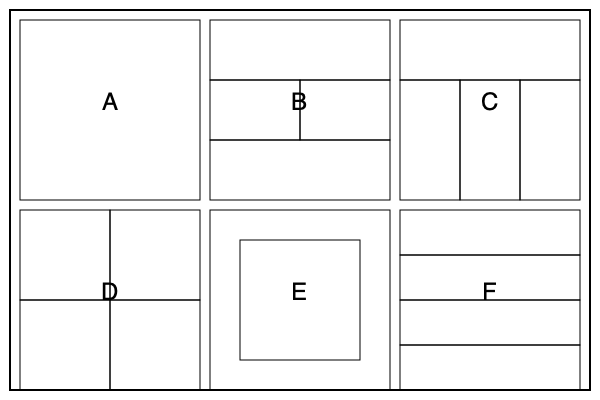Analyze the six panel layout grids (A-F) shown above. Which layout would be most effective for depicting a tense confrontation between two characters, where one character gradually gains the upper hand? Explain your choice, considering pacing, visual flow, and dramatic impact. To answer this question, we need to consider how each layout can contribute to storytelling, particularly for a tense confrontation with a gradual power shift. Let's analyze each layout:

1. Layout A: Single large panel. This could work for a dramatic moment but lacks the ability to show gradual change.

2. Layout B: Four panels with varying sizes. This layout offers a good balance of pacing and visual interest.

3. Layout C: One wide panel followed by three vertical panels. This layout can effectively show a progression of events.

4. Layout D: Four equal-sized panels. While simple, this layout can be effective for showing a step-by-step progression.

5. Layout E: A large panel with a smaller inset panel. This layout can emphasize one moment while providing additional detail or contrast.

6. Layout F: Four equal horizontal panels. This layout is excellent for showing a gradual progression over time.

For a tense confrontation where one character gradually gains the upper hand, Layout C would be the most effective choice for the following reasons:

1. Pacing: The initial wide panel can establish the scene and characters, while the three vertical panels allow for a clear progression of the confrontation.

2. Visual flow: The vertical panels naturally guide the reader's eye downward, creating a sense of building tension and inevitability.

3. Dramatic impact: The narrow vertical panels can be used to focus on character expressions or key actions, intensifying the emotional impact of each stage of the confrontation.

4. Power dynamics: The vertical panels can visually represent the changing power dynamic between the characters. For example, the character gaining the upper hand could be depicted as physically higher in each successive panel.

5. Flexibility: This layout allows for various artistic techniques, such as using the vertical panels to zoom in on crucial details or to alternate between the two characters' perspectives.

Layout C provides the best combination of elements to depict the gradual shift in power during a tense confrontation, making it the most effective choice for this particular storytelling scenario.
Answer: Layout C 